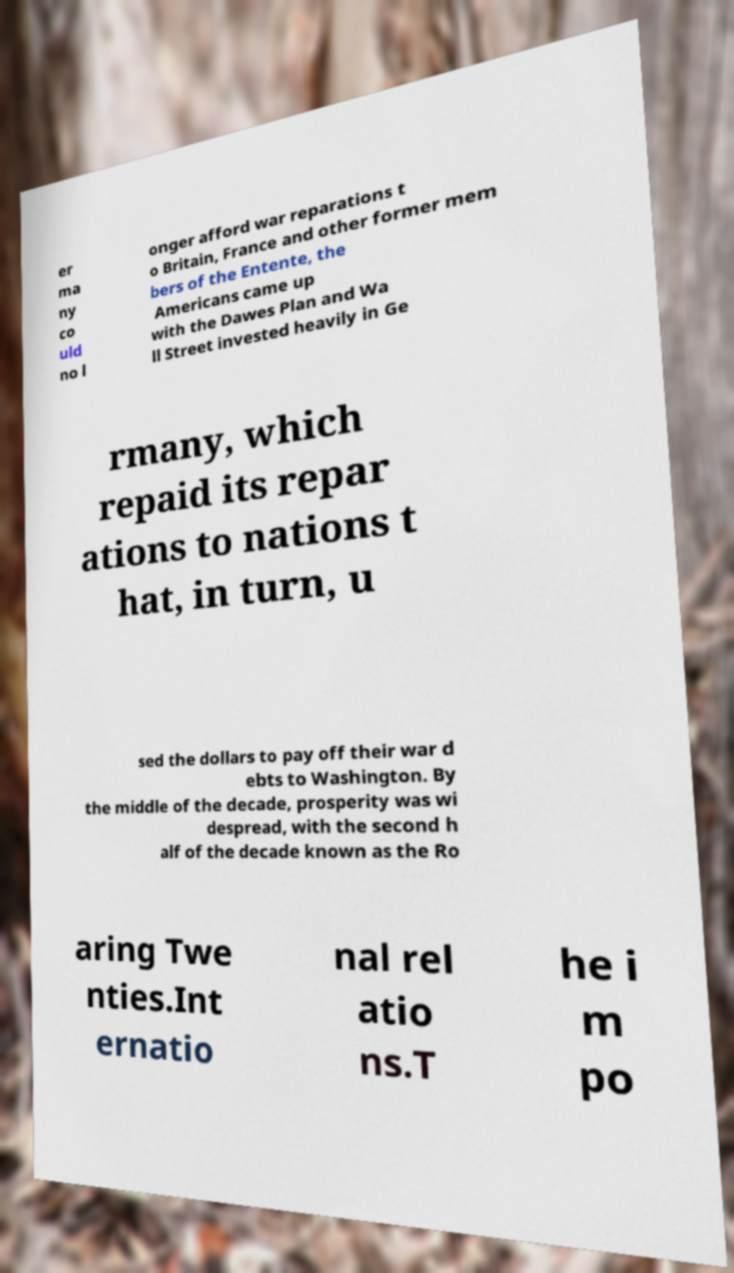Please identify and transcribe the text found in this image. er ma ny co uld no l onger afford war reparations t o Britain, France and other former mem bers of the Entente, the Americans came up with the Dawes Plan and Wa ll Street invested heavily in Ge rmany, which repaid its repar ations to nations t hat, in turn, u sed the dollars to pay off their war d ebts to Washington. By the middle of the decade, prosperity was wi despread, with the second h alf of the decade known as the Ro aring Twe nties.Int ernatio nal rel atio ns.T he i m po 